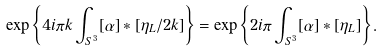<formula> <loc_0><loc_0><loc_500><loc_500>\exp \left \{ 4 i \pi k \int _ { S ^ { 3 } } [ \alpha ] \ast [ \eta _ { L } / 2 k ] \right \} = \exp \left \{ 2 i \pi \int _ { S ^ { 3 } } [ \alpha ] \ast [ \eta _ { L } ] \right \} .</formula> 